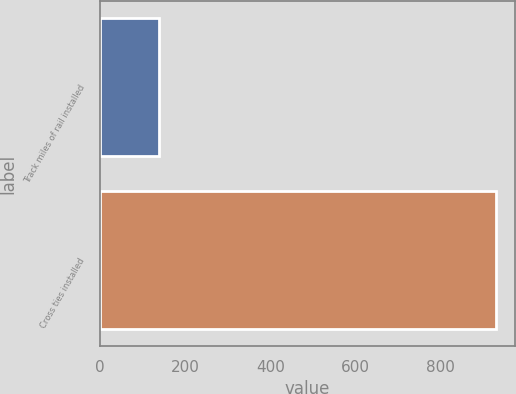Convert chart. <chart><loc_0><loc_0><loc_500><loc_500><bar_chart><fcel>Track miles of rail installed<fcel>Cross ties installed<nl><fcel>138<fcel>929<nl></chart> 